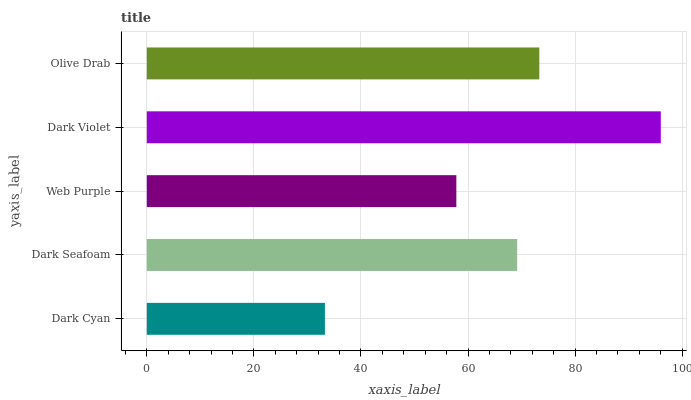Is Dark Cyan the minimum?
Answer yes or no. Yes. Is Dark Violet the maximum?
Answer yes or no. Yes. Is Dark Seafoam the minimum?
Answer yes or no. No. Is Dark Seafoam the maximum?
Answer yes or no. No. Is Dark Seafoam greater than Dark Cyan?
Answer yes or no. Yes. Is Dark Cyan less than Dark Seafoam?
Answer yes or no. Yes. Is Dark Cyan greater than Dark Seafoam?
Answer yes or no. No. Is Dark Seafoam less than Dark Cyan?
Answer yes or no. No. Is Dark Seafoam the high median?
Answer yes or no. Yes. Is Dark Seafoam the low median?
Answer yes or no. Yes. Is Dark Cyan the high median?
Answer yes or no. No. Is Dark Violet the low median?
Answer yes or no. No. 